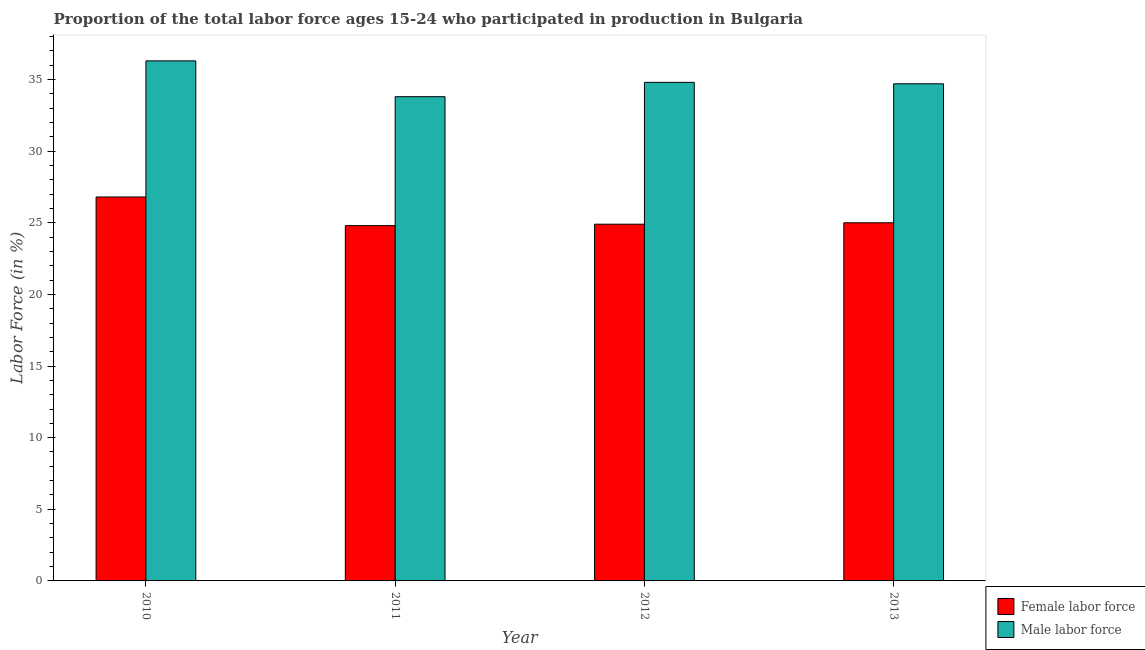How many different coloured bars are there?
Offer a terse response. 2. How many groups of bars are there?
Make the answer very short. 4. Are the number of bars per tick equal to the number of legend labels?
Keep it short and to the point. Yes. Are the number of bars on each tick of the X-axis equal?
Your response must be concise. Yes. How many bars are there on the 3rd tick from the left?
Provide a short and direct response. 2. How many bars are there on the 3rd tick from the right?
Make the answer very short. 2. What is the label of the 2nd group of bars from the left?
Give a very brief answer. 2011. In how many cases, is the number of bars for a given year not equal to the number of legend labels?
Ensure brevity in your answer.  0. What is the percentage of male labour force in 2010?
Ensure brevity in your answer.  36.3. Across all years, what is the maximum percentage of male labour force?
Ensure brevity in your answer.  36.3. Across all years, what is the minimum percentage of female labor force?
Provide a short and direct response. 24.8. What is the total percentage of female labor force in the graph?
Offer a terse response. 101.5. What is the difference between the percentage of female labor force in 2011 and that in 2013?
Provide a short and direct response. -0.2. What is the difference between the percentage of female labor force in 2012 and the percentage of male labour force in 2010?
Your response must be concise. -1.9. What is the average percentage of male labour force per year?
Your response must be concise. 34.9. In how many years, is the percentage of female labor force greater than 8 %?
Provide a succinct answer. 4. What is the ratio of the percentage of male labour force in 2012 to that in 2013?
Make the answer very short. 1. Is the percentage of female labor force in 2010 less than that in 2012?
Your response must be concise. No. Is the difference between the percentage of male labour force in 2010 and 2012 greater than the difference between the percentage of female labor force in 2010 and 2012?
Offer a terse response. No. What is the difference between the highest and the second highest percentage of female labor force?
Provide a succinct answer. 1.8. What is the difference between the highest and the lowest percentage of female labor force?
Your answer should be very brief. 2. In how many years, is the percentage of female labor force greater than the average percentage of female labor force taken over all years?
Offer a terse response. 1. Is the sum of the percentage of male labour force in 2011 and 2013 greater than the maximum percentage of female labor force across all years?
Make the answer very short. Yes. What does the 1st bar from the left in 2010 represents?
Provide a short and direct response. Female labor force. What does the 1st bar from the right in 2013 represents?
Give a very brief answer. Male labor force. Are all the bars in the graph horizontal?
Offer a terse response. No. How many years are there in the graph?
Your answer should be very brief. 4. What is the difference between two consecutive major ticks on the Y-axis?
Make the answer very short. 5. Are the values on the major ticks of Y-axis written in scientific E-notation?
Your answer should be very brief. No. Does the graph contain any zero values?
Offer a terse response. No. Where does the legend appear in the graph?
Keep it short and to the point. Bottom right. How are the legend labels stacked?
Keep it short and to the point. Vertical. What is the title of the graph?
Your answer should be compact. Proportion of the total labor force ages 15-24 who participated in production in Bulgaria. Does "Money lenders" appear as one of the legend labels in the graph?
Your response must be concise. No. What is the label or title of the X-axis?
Your answer should be very brief. Year. What is the label or title of the Y-axis?
Make the answer very short. Labor Force (in %). What is the Labor Force (in %) of Female labor force in 2010?
Keep it short and to the point. 26.8. What is the Labor Force (in %) in Male labor force in 2010?
Keep it short and to the point. 36.3. What is the Labor Force (in %) in Female labor force in 2011?
Make the answer very short. 24.8. What is the Labor Force (in %) of Male labor force in 2011?
Give a very brief answer. 33.8. What is the Labor Force (in %) in Female labor force in 2012?
Offer a very short reply. 24.9. What is the Labor Force (in %) in Male labor force in 2012?
Your response must be concise. 34.8. What is the Labor Force (in %) of Male labor force in 2013?
Give a very brief answer. 34.7. Across all years, what is the maximum Labor Force (in %) in Female labor force?
Offer a very short reply. 26.8. Across all years, what is the maximum Labor Force (in %) in Male labor force?
Your response must be concise. 36.3. Across all years, what is the minimum Labor Force (in %) in Female labor force?
Give a very brief answer. 24.8. Across all years, what is the minimum Labor Force (in %) of Male labor force?
Your answer should be compact. 33.8. What is the total Labor Force (in %) of Female labor force in the graph?
Your answer should be compact. 101.5. What is the total Labor Force (in %) of Male labor force in the graph?
Give a very brief answer. 139.6. What is the difference between the Labor Force (in %) of Female labor force in 2010 and that in 2011?
Make the answer very short. 2. What is the difference between the Labor Force (in %) in Male labor force in 2010 and that in 2011?
Your response must be concise. 2.5. What is the difference between the Labor Force (in %) in Female labor force in 2010 and that in 2012?
Keep it short and to the point. 1.9. What is the difference between the Labor Force (in %) of Female labor force in 2010 and that in 2013?
Your answer should be very brief. 1.8. What is the difference between the Labor Force (in %) in Female labor force in 2012 and that in 2013?
Your answer should be very brief. -0.1. What is the difference between the Labor Force (in %) in Female labor force in 2011 and the Labor Force (in %) in Male labor force in 2013?
Make the answer very short. -9.9. What is the difference between the Labor Force (in %) in Female labor force in 2012 and the Labor Force (in %) in Male labor force in 2013?
Your answer should be compact. -9.8. What is the average Labor Force (in %) of Female labor force per year?
Make the answer very short. 25.38. What is the average Labor Force (in %) in Male labor force per year?
Give a very brief answer. 34.9. In the year 2010, what is the difference between the Labor Force (in %) of Female labor force and Labor Force (in %) of Male labor force?
Keep it short and to the point. -9.5. What is the ratio of the Labor Force (in %) of Female labor force in 2010 to that in 2011?
Provide a succinct answer. 1.08. What is the ratio of the Labor Force (in %) of Male labor force in 2010 to that in 2011?
Provide a short and direct response. 1.07. What is the ratio of the Labor Force (in %) in Female labor force in 2010 to that in 2012?
Provide a short and direct response. 1.08. What is the ratio of the Labor Force (in %) of Male labor force in 2010 to that in 2012?
Keep it short and to the point. 1.04. What is the ratio of the Labor Force (in %) of Female labor force in 2010 to that in 2013?
Your answer should be compact. 1.07. What is the ratio of the Labor Force (in %) of Male labor force in 2010 to that in 2013?
Make the answer very short. 1.05. What is the ratio of the Labor Force (in %) of Female labor force in 2011 to that in 2012?
Keep it short and to the point. 1. What is the ratio of the Labor Force (in %) of Male labor force in 2011 to that in 2012?
Give a very brief answer. 0.97. What is the ratio of the Labor Force (in %) of Female labor force in 2011 to that in 2013?
Offer a very short reply. 0.99. What is the ratio of the Labor Force (in %) of Male labor force in 2011 to that in 2013?
Offer a terse response. 0.97. What is the ratio of the Labor Force (in %) of Male labor force in 2012 to that in 2013?
Provide a short and direct response. 1. What is the difference between the highest and the second highest Labor Force (in %) of Female labor force?
Give a very brief answer. 1.8. 